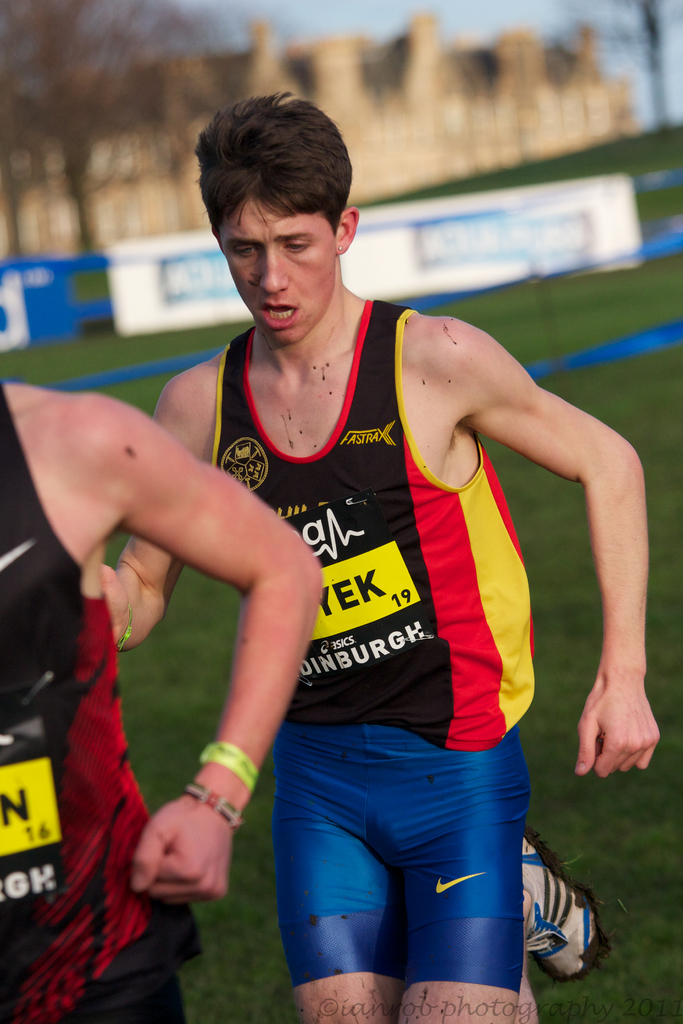Provide a one-sentence caption for the provided image. A young athlete, wearing a FASTRAX jerseyn, visibly exhausts as he competes in a cross-country event, with a historic castle faintly visible in the background. 